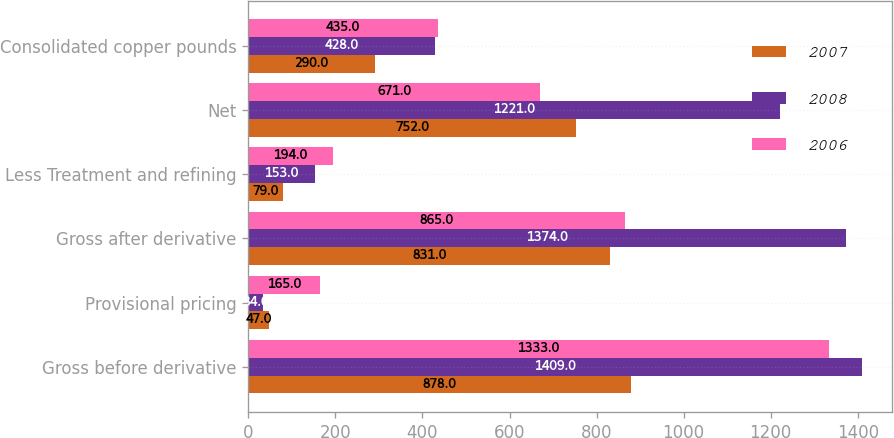Convert chart. <chart><loc_0><loc_0><loc_500><loc_500><stacked_bar_chart><ecel><fcel>Gross before derivative<fcel>Provisional pricing<fcel>Gross after derivative<fcel>Less Treatment and refining<fcel>Net<fcel>Consolidated copper pounds<nl><fcel>2007<fcel>878<fcel>47<fcel>831<fcel>79<fcel>752<fcel>290<nl><fcel>2008<fcel>1409<fcel>34<fcel>1374<fcel>153<fcel>1221<fcel>428<nl><fcel>2006<fcel>1333<fcel>165<fcel>865<fcel>194<fcel>671<fcel>435<nl></chart> 